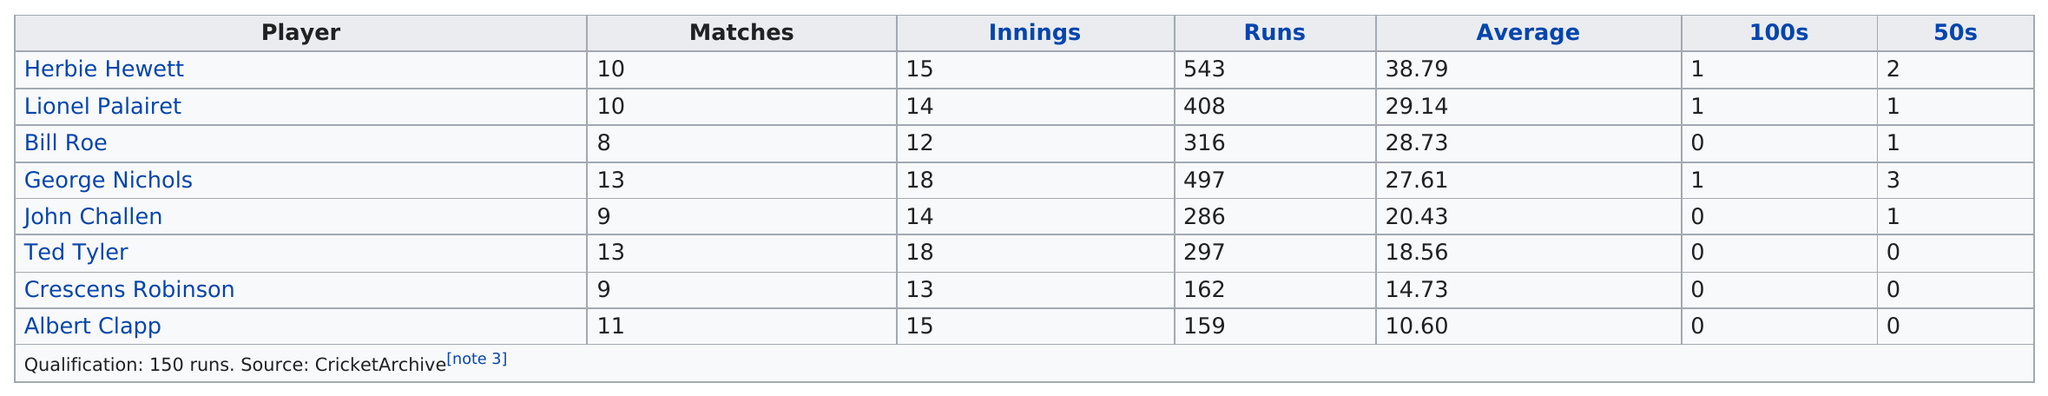Identify some key points in this picture. Out of the total number of players who played more than 10 matches, 3 players were identified. The total amount of runs accumulated by everyone is 2668. The least amount of runs anyone has is 159. The total number of innings played by Bill and Ted was 30 innings. Albert Clapp, the player with the least amount of runs, achieved this feat. 